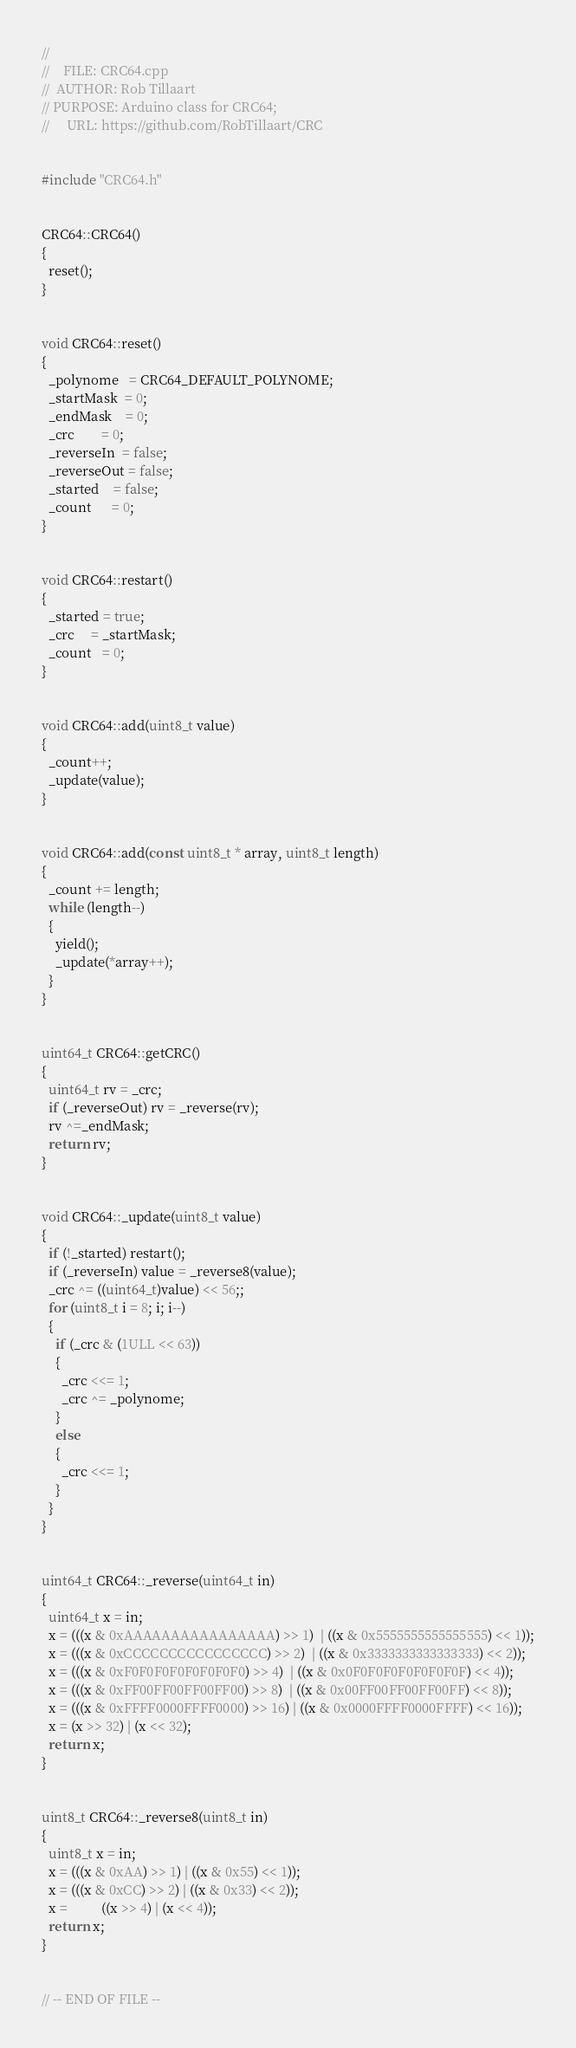Convert code to text. <code><loc_0><loc_0><loc_500><loc_500><_C++_>//
//    FILE: CRC64.cpp
//  AUTHOR: Rob Tillaart
// PURPOSE: Arduino class for CRC64;
//     URL: https://github.com/RobTillaart/CRC


#include "CRC64.h"


CRC64::CRC64()
{
  reset();
}


void CRC64::reset()
{
  _polynome   = CRC64_DEFAULT_POLYNOME;
  _startMask  = 0;
  _endMask    = 0;
  _crc        = 0;
  _reverseIn  = false;
  _reverseOut = false;
  _started    = false;
  _count      = 0;
}


void CRC64::restart()
{
  _started = true;
  _crc     = _startMask;
  _count   = 0;
}


void CRC64::add(uint8_t value)
{
  _count++;
  _update(value);
}


void CRC64::add(const uint8_t * array, uint8_t length)
{
  _count += length;
  while (length--)
  {
    yield();
    _update(*array++);
  }
}


uint64_t CRC64::getCRC()
{
  uint64_t rv = _crc;
  if (_reverseOut) rv = _reverse(rv);
  rv ^=_endMask;
  return rv;
}


void CRC64::_update(uint8_t value)
{
  if (!_started) restart();
  if (_reverseIn) value = _reverse8(value);
  _crc ^= ((uint64_t)value) << 56;;
  for (uint8_t i = 8; i; i--) 
  {
    if (_crc & (1ULL << 63))
    {
      _crc <<= 1;
      _crc ^= _polynome;
    }
    else
    {
      _crc <<= 1;
    }
  }
}


uint64_t CRC64::_reverse(uint64_t in)
{
  uint64_t x = in;
  x = (((x & 0xAAAAAAAAAAAAAAAA) >> 1)  | ((x & 0x5555555555555555) << 1));
  x = (((x & 0xCCCCCCCCCCCCCCCC) >> 2)  | ((x & 0x3333333333333333) << 2));
  x = (((x & 0xF0F0F0F0F0F0F0F0) >> 4)  | ((x & 0x0F0F0F0F0F0F0F0F) << 4));
  x = (((x & 0xFF00FF00FF00FF00) >> 8)  | ((x & 0x00FF00FF00FF00FF) << 8));
  x = (((x & 0xFFFF0000FFFF0000) >> 16) | ((x & 0x0000FFFF0000FFFF) << 16));
  x = (x >> 32) | (x << 32);
  return x;
}


uint8_t CRC64::_reverse8(uint8_t in)
{
  uint8_t x = in;
  x = (((x & 0xAA) >> 1) | ((x & 0x55) << 1));
  x = (((x & 0xCC) >> 2) | ((x & 0x33) << 2));
  x =          ((x >> 4) | (x << 4));
  return x;
}


// -- END OF FILE --

</code> 